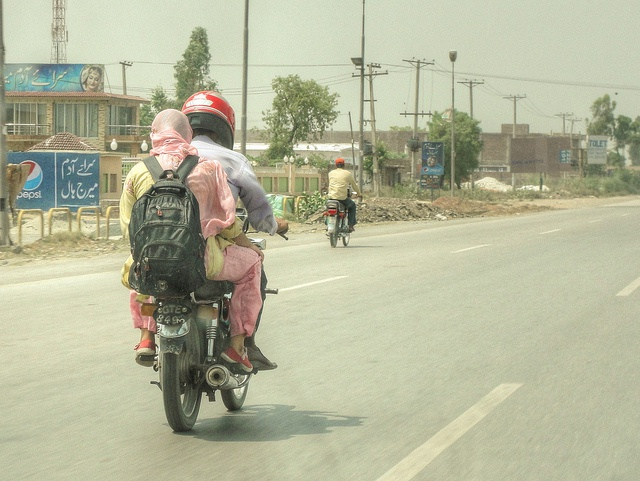Describe the objects in this image and their specific colors. I can see people in gray and tan tones, backpack in gray, black, and darkgray tones, motorcycle in gray, black, darkgreen, and darkgray tones, people in gray, lightgray, darkgray, and black tones, and people in gray, khaki, tan, and lightyellow tones in this image. 